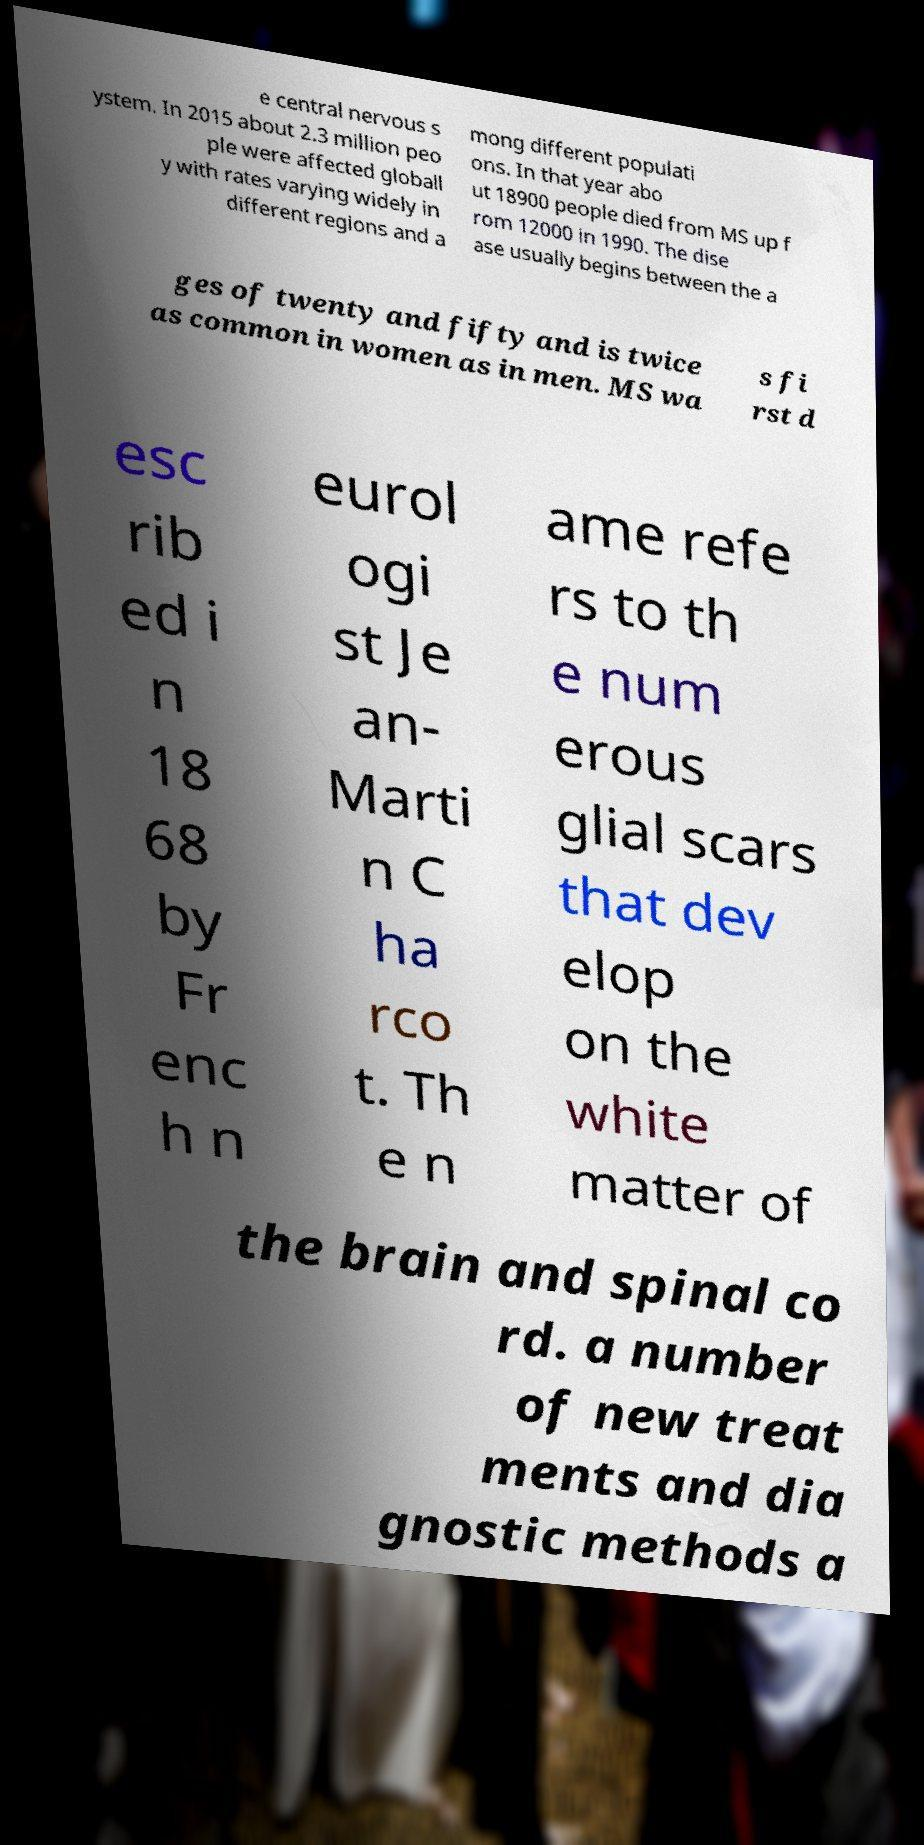What messages or text are displayed in this image? I need them in a readable, typed format. e central nervous s ystem. In 2015 about 2.3 million peo ple were affected globall y with rates varying widely in different regions and a mong different populati ons. In that year abo ut 18900 people died from MS up f rom 12000 in 1990. The dise ase usually begins between the a ges of twenty and fifty and is twice as common in women as in men. MS wa s fi rst d esc rib ed i n 18 68 by Fr enc h n eurol ogi st Je an- Marti n C ha rco t. Th e n ame refe rs to th e num erous glial scars that dev elop on the white matter of the brain and spinal co rd. a number of new treat ments and dia gnostic methods a 